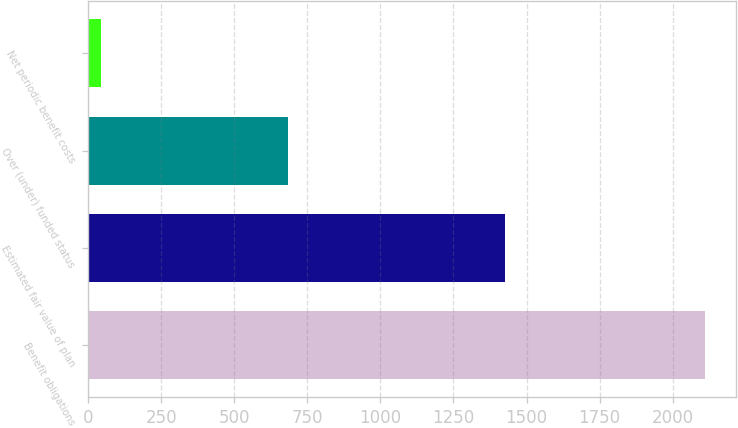Convert chart. <chart><loc_0><loc_0><loc_500><loc_500><bar_chart><fcel>Benefit obligations<fcel>Estimated fair value of plan<fcel>Over (under) funded status<fcel>Net periodic benefit costs<nl><fcel>2110<fcel>1426<fcel>684<fcel>43<nl></chart> 